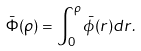Convert formula to latex. <formula><loc_0><loc_0><loc_500><loc_500>\bar { \Phi } ( \rho ) = \int _ { 0 } ^ { \rho } \bar { \phi } ( r ) d r .</formula> 